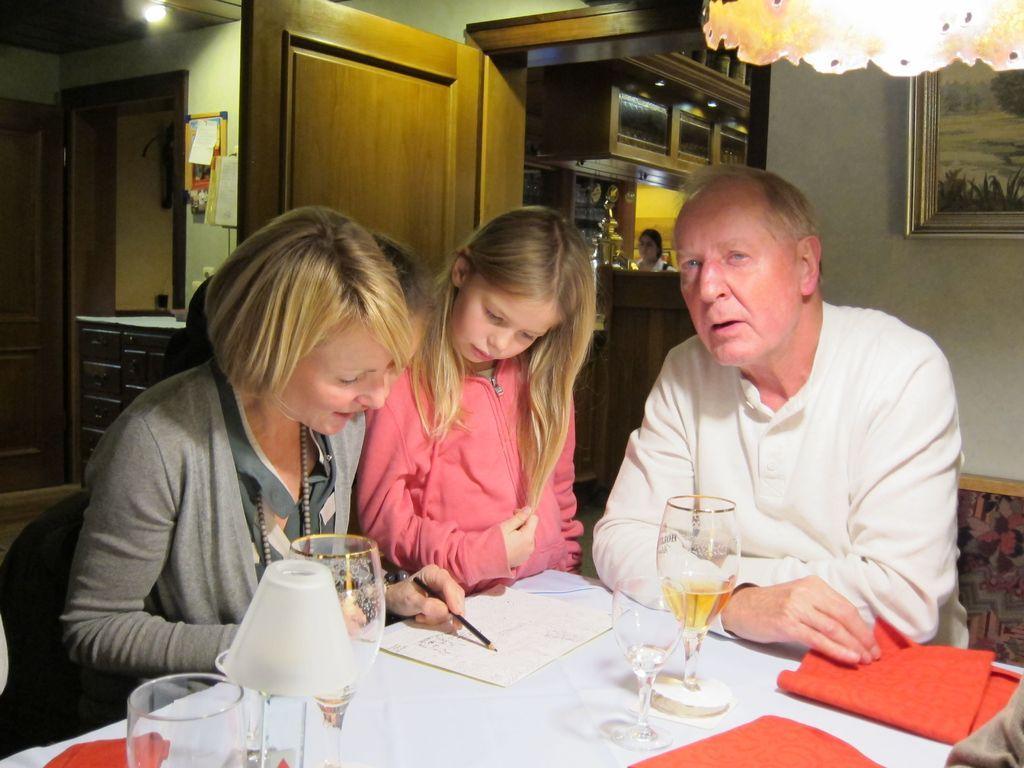In one or two sentences, can you explain what this image depicts? In the left side a beautiful woman is sitting on the chair and pointing her finger with a pencil. There are wine glasses on this table beside her, there is a cute girl, she wore a pink color sweater and in the right side of an image a man is sitting. He wore a white color dress, behind him it's a wall. 